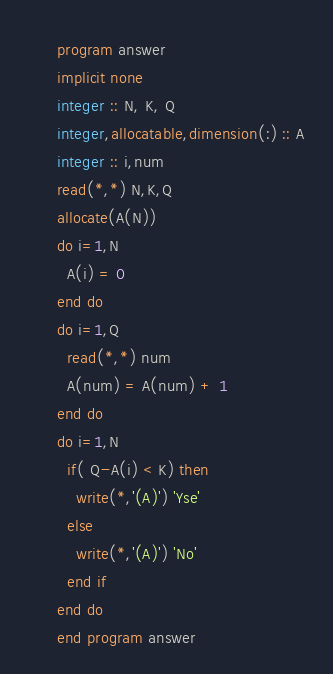<code> <loc_0><loc_0><loc_500><loc_500><_FORTRAN_>      program answer
      implicit none
      integer :: N, K, Q
      integer,allocatable,dimension(:) :: A
      integer :: i,num
      read(*,*) N,K,Q
      allocate(A(N))
      do i=1,N
        A(i) = 0
      end do
      do i=1,Q
        read(*,*) num
        A(num) = A(num) + 1
      end do
      do i=1,N
        if( Q-A(i) < K) then
          write(*,'(A)') 'Yse'
        else
          write(*,'(A)') 'No'
        end if
      end do
      end program answer</code> 